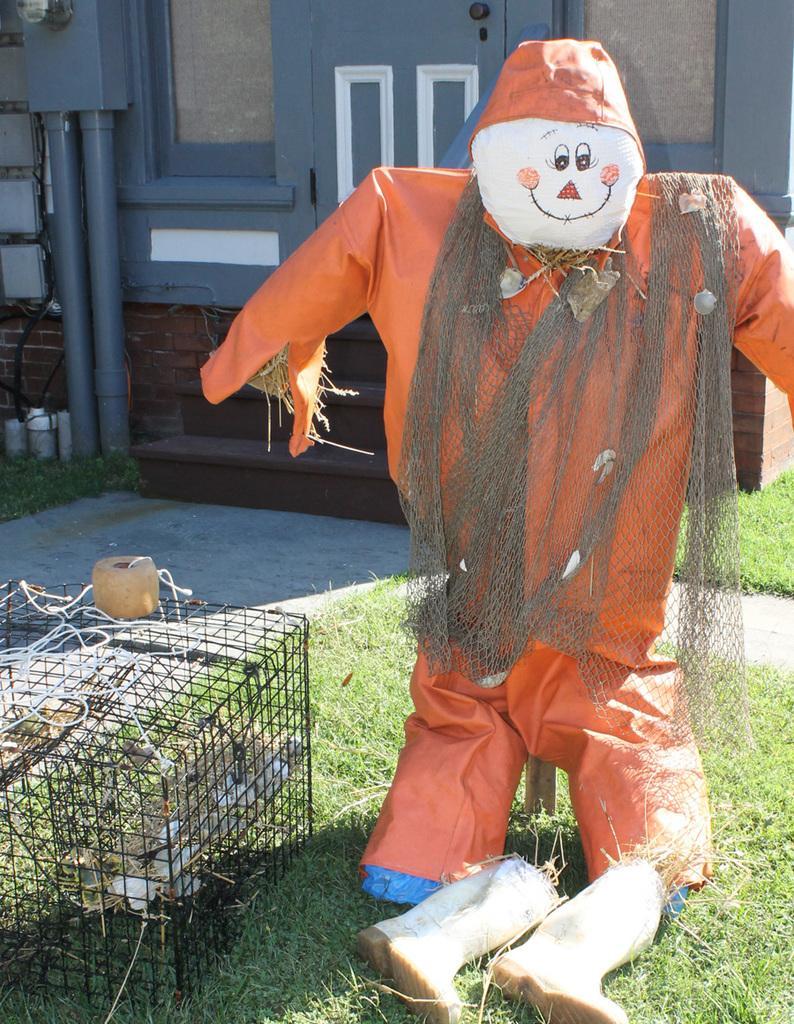How would you summarize this image in a sentence or two? In this image, in the middle, we can see a statue. On the left side, we can also see a grill box, in the grill box, we can see some birds. In the background, we can see some buildings and pillar. 